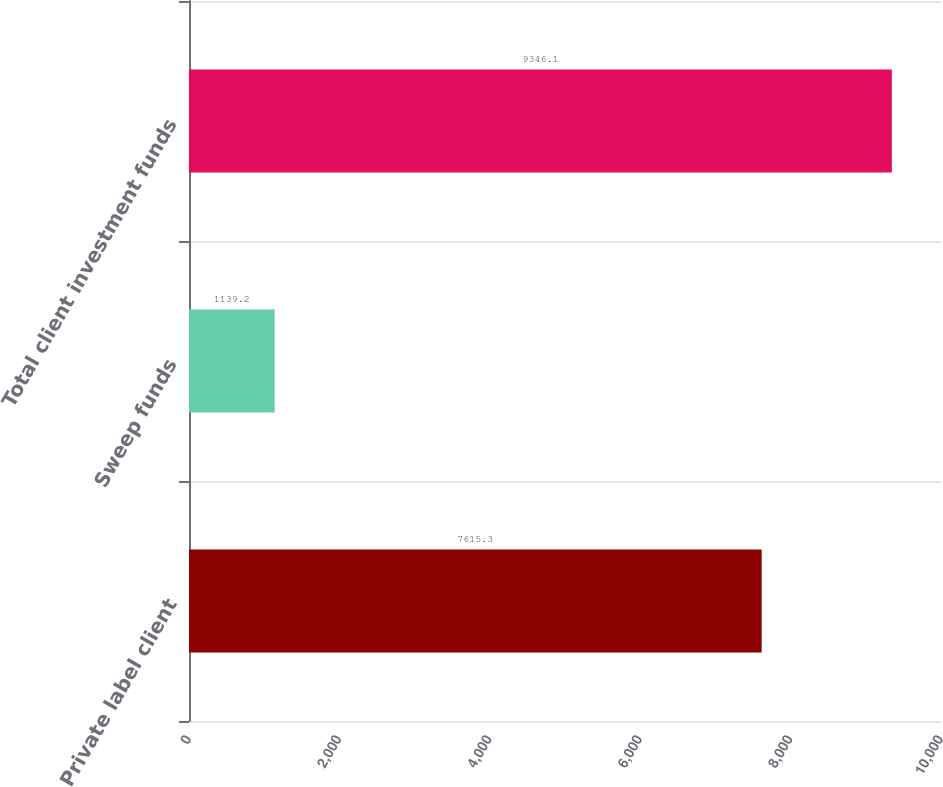Convert chart. <chart><loc_0><loc_0><loc_500><loc_500><bar_chart><fcel>Private label client<fcel>Sweep funds<fcel>Total client investment funds<nl><fcel>7615.3<fcel>1139.2<fcel>9346.1<nl></chart> 